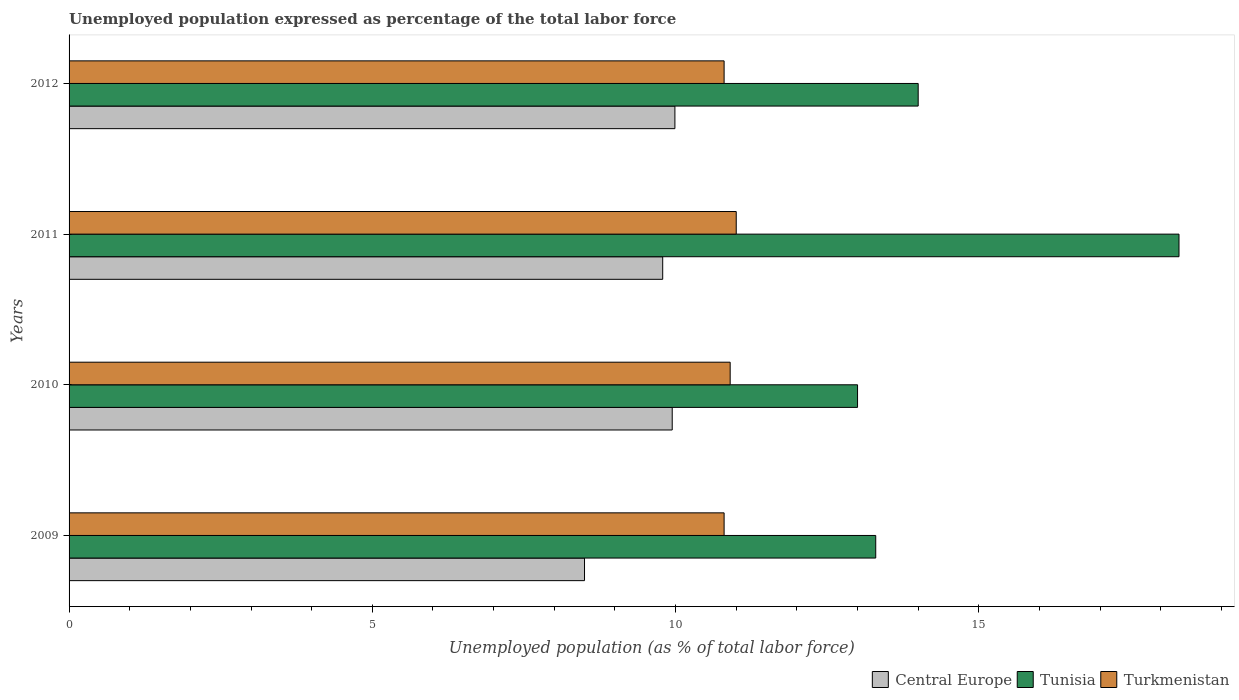Are the number of bars on each tick of the Y-axis equal?
Offer a very short reply. Yes. How many bars are there on the 1st tick from the top?
Provide a succinct answer. 3. How many bars are there on the 2nd tick from the bottom?
Give a very brief answer. 3. What is the unemployment in in Tunisia in 2012?
Provide a short and direct response. 14. Across all years, what is the minimum unemployment in in Central Europe?
Keep it short and to the point. 8.5. What is the total unemployment in in Central Europe in the graph?
Provide a succinct answer. 38.22. What is the difference between the unemployment in in Tunisia in 2010 and that in 2012?
Make the answer very short. -1. What is the difference between the unemployment in in Central Europe in 2010 and the unemployment in in Tunisia in 2011?
Your answer should be compact. -8.36. What is the average unemployment in in Central Europe per year?
Provide a short and direct response. 9.55. In the year 2010, what is the difference between the unemployment in in Central Europe and unemployment in in Tunisia?
Your response must be concise. -3.06. What is the ratio of the unemployment in in Central Europe in 2010 to that in 2011?
Give a very brief answer. 1.02. What is the difference between the highest and the second highest unemployment in in Tunisia?
Provide a succinct answer. 4.3. What is the difference between the highest and the lowest unemployment in in Turkmenistan?
Offer a very short reply. 0.2. In how many years, is the unemployment in in Turkmenistan greater than the average unemployment in in Turkmenistan taken over all years?
Offer a terse response. 2. What does the 1st bar from the top in 2011 represents?
Offer a terse response. Turkmenistan. What does the 3rd bar from the bottom in 2009 represents?
Offer a terse response. Turkmenistan. Is it the case that in every year, the sum of the unemployment in in Tunisia and unemployment in in Central Europe is greater than the unemployment in in Turkmenistan?
Give a very brief answer. Yes. How many bars are there?
Keep it short and to the point. 12. Does the graph contain any zero values?
Provide a short and direct response. No. Where does the legend appear in the graph?
Offer a very short reply. Bottom right. How many legend labels are there?
Give a very brief answer. 3. What is the title of the graph?
Give a very brief answer. Unemployed population expressed as percentage of the total labor force. Does "Brazil" appear as one of the legend labels in the graph?
Your response must be concise. No. What is the label or title of the X-axis?
Offer a very short reply. Unemployed population (as % of total labor force). What is the label or title of the Y-axis?
Give a very brief answer. Years. What is the Unemployed population (as % of total labor force) in Central Europe in 2009?
Give a very brief answer. 8.5. What is the Unemployed population (as % of total labor force) of Tunisia in 2009?
Provide a short and direct response. 13.3. What is the Unemployed population (as % of total labor force) of Turkmenistan in 2009?
Your answer should be very brief. 10.8. What is the Unemployed population (as % of total labor force) of Central Europe in 2010?
Offer a terse response. 9.94. What is the Unemployed population (as % of total labor force) of Turkmenistan in 2010?
Your answer should be compact. 10.9. What is the Unemployed population (as % of total labor force) of Central Europe in 2011?
Provide a succinct answer. 9.79. What is the Unemployed population (as % of total labor force) of Tunisia in 2011?
Your answer should be very brief. 18.3. What is the Unemployed population (as % of total labor force) in Turkmenistan in 2011?
Your answer should be compact. 11. What is the Unemployed population (as % of total labor force) of Central Europe in 2012?
Give a very brief answer. 9.99. What is the Unemployed population (as % of total labor force) in Tunisia in 2012?
Your response must be concise. 14. What is the Unemployed population (as % of total labor force) in Turkmenistan in 2012?
Your answer should be very brief. 10.8. Across all years, what is the maximum Unemployed population (as % of total labor force) in Central Europe?
Ensure brevity in your answer.  9.99. Across all years, what is the maximum Unemployed population (as % of total labor force) of Tunisia?
Your answer should be very brief. 18.3. Across all years, what is the maximum Unemployed population (as % of total labor force) of Turkmenistan?
Provide a succinct answer. 11. Across all years, what is the minimum Unemployed population (as % of total labor force) in Central Europe?
Keep it short and to the point. 8.5. Across all years, what is the minimum Unemployed population (as % of total labor force) of Tunisia?
Provide a short and direct response. 13. Across all years, what is the minimum Unemployed population (as % of total labor force) of Turkmenistan?
Make the answer very short. 10.8. What is the total Unemployed population (as % of total labor force) in Central Europe in the graph?
Your response must be concise. 38.22. What is the total Unemployed population (as % of total labor force) of Tunisia in the graph?
Your answer should be very brief. 58.6. What is the total Unemployed population (as % of total labor force) of Turkmenistan in the graph?
Offer a very short reply. 43.5. What is the difference between the Unemployed population (as % of total labor force) in Central Europe in 2009 and that in 2010?
Your answer should be very brief. -1.45. What is the difference between the Unemployed population (as % of total labor force) in Turkmenistan in 2009 and that in 2010?
Keep it short and to the point. -0.1. What is the difference between the Unemployed population (as % of total labor force) in Central Europe in 2009 and that in 2011?
Offer a terse response. -1.29. What is the difference between the Unemployed population (as % of total labor force) in Tunisia in 2009 and that in 2011?
Your answer should be compact. -5. What is the difference between the Unemployed population (as % of total labor force) of Turkmenistan in 2009 and that in 2011?
Provide a short and direct response. -0.2. What is the difference between the Unemployed population (as % of total labor force) of Central Europe in 2009 and that in 2012?
Give a very brief answer. -1.49. What is the difference between the Unemployed population (as % of total labor force) of Turkmenistan in 2009 and that in 2012?
Give a very brief answer. 0. What is the difference between the Unemployed population (as % of total labor force) of Central Europe in 2010 and that in 2011?
Your response must be concise. 0.16. What is the difference between the Unemployed population (as % of total labor force) in Tunisia in 2010 and that in 2011?
Provide a succinct answer. -5.3. What is the difference between the Unemployed population (as % of total labor force) in Turkmenistan in 2010 and that in 2011?
Give a very brief answer. -0.1. What is the difference between the Unemployed population (as % of total labor force) of Central Europe in 2010 and that in 2012?
Offer a terse response. -0.04. What is the difference between the Unemployed population (as % of total labor force) in Turkmenistan in 2010 and that in 2012?
Keep it short and to the point. 0.1. What is the difference between the Unemployed population (as % of total labor force) in Central Europe in 2011 and that in 2012?
Your answer should be very brief. -0.2. What is the difference between the Unemployed population (as % of total labor force) of Tunisia in 2011 and that in 2012?
Offer a very short reply. 4.3. What is the difference between the Unemployed population (as % of total labor force) in Central Europe in 2009 and the Unemployed population (as % of total labor force) in Tunisia in 2010?
Your answer should be compact. -4.5. What is the difference between the Unemployed population (as % of total labor force) of Central Europe in 2009 and the Unemployed population (as % of total labor force) of Turkmenistan in 2010?
Offer a terse response. -2.4. What is the difference between the Unemployed population (as % of total labor force) in Tunisia in 2009 and the Unemployed population (as % of total labor force) in Turkmenistan in 2010?
Ensure brevity in your answer.  2.4. What is the difference between the Unemployed population (as % of total labor force) in Central Europe in 2009 and the Unemployed population (as % of total labor force) in Tunisia in 2011?
Your answer should be compact. -9.8. What is the difference between the Unemployed population (as % of total labor force) in Central Europe in 2009 and the Unemployed population (as % of total labor force) in Turkmenistan in 2011?
Make the answer very short. -2.5. What is the difference between the Unemployed population (as % of total labor force) of Central Europe in 2009 and the Unemployed population (as % of total labor force) of Tunisia in 2012?
Your answer should be very brief. -5.5. What is the difference between the Unemployed population (as % of total labor force) in Central Europe in 2009 and the Unemployed population (as % of total labor force) in Turkmenistan in 2012?
Make the answer very short. -2.3. What is the difference between the Unemployed population (as % of total labor force) in Tunisia in 2009 and the Unemployed population (as % of total labor force) in Turkmenistan in 2012?
Your answer should be very brief. 2.5. What is the difference between the Unemployed population (as % of total labor force) of Central Europe in 2010 and the Unemployed population (as % of total labor force) of Tunisia in 2011?
Your answer should be compact. -8.36. What is the difference between the Unemployed population (as % of total labor force) in Central Europe in 2010 and the Unemployed population (as % of total labor force) in Turkmenistan in 2011?
Offer a terse response. -1.06. What is the difference between the Unemployed population (as % of total labor force) in Tunisia in 2010 and the Unemployed population (as % of total labor force) in Turkmenistan in 2011?
Ensure brevity in your answer.  2. What is the difference between the Unemployed population (as % of total labor force) in Central Europe in 2010 and the Unemployed population (as % of total labor force) in Tunisia in 2012?
Your answer should be compact. -4.06. What is the difference between the Unemployed population (as % of total labor force) of Central Europe in 2010 and the Unemployed population (as % of total labor force) of Turkmenistan in 2012?
Your answer should be compact. -0.86. What is the difference between the Unemployed population (as % of total labor force) in Central Europe in 2011 and the Unemployed population (as % of total labor force) in Tunisia in 2012?
Provide a short and direct response. -4.21. What is the difference between the Unemployed population (as % of total labor force) of Central Europe in 2011 and the Unemployed population (as % of total labor force) of Turkmenistan in 2012?
Offer a terse response. -1.01. What is the difference between the Unemployed population (as % of total labor force) of Tunisia in 2011 and the Unemployed population (as % of total labor force) of Turkmenistan in 2012?
Offer a very short reply. 7.5. What is the average Unemployed population (as % of total labor force) in Central Europe per year?
Your answer should be compact. 9.55. What is the average Unemployed population (as % of total labor force) in Tunisia per year?
Provide a succinct answer. 14.65. What is the average Unemployed population (as % of total labor force) in Turkmenistan per year?
Give a very brief answer. 10.88. In the year 2009, what is the difference between the Unemployed population (as % of total labor force) in Central Europe and Unemployed population (as % of total labor force) in Tunisia?
Provide a succinct answer. -4.8. In the year 2009, what is the difference between the Unemployed population (as % of total labor force) of Central Europe and Unemployed population (as % of total labor force) of Turkmenistan?
Your answer should be compact. -2.3. In the year 2010, what is the difference between the Unemployed population (as % of total labor force) of Central Europe and Unemployed population (as % of total labor force) of Tunisia?
Your answer should be compact. -3.06. In the year 2010, what is the difference between the Unemployed population (as % of total labor force) in Central Europe and Unemployed population (as % of total labor force) in Turkmenistan?
Give a very brief answer. -0.96. In the year 2010, what is the difference between the Unemployed population (as % of total labor force) in Tunisia and Unemployed population (as % of total labor force) in Turkmenistan?
Offer a terse response. 2.1. In the year 2011, what is the difference between the Unemployed population (as % of total labor force) of Central Europe and Unemployed population (as % of total labor force) of Tunisia?
Make the answer very short. -8.51. In the year 2011, what is the difference between the Unemployed population (as % of total labor force) in Central Europe and Unemployed population (as % of total labor force) in Turkmenistan?
Ensure brevity in your answer.  -1.21. In the year 2012, what is the difference between the Unemployed population (as % of total labor force) of Central Europe and Unemployed population (as % of total labor force) of Tunisia?
Your answer should be very brief. -4.01. In the year 2012, what is the difference between the Unemployed population (as % of total labor force) of Central Europe and Unemployed population (as % of total labor force) of Turkmenistan?
Provide a short and direct response. -0.81. What is the ratio of the Unemployed population (as % of total labor force) in Central Europe in 2009 to that in 2010?
Offer a terse response. 0.85. What is the ratio of the Unemployed population (as % of total labor force) in Tunisia in 2009 to that in 2010?
Give a very brief answer. 1.02. What is the ratio of the Unemployed population (as % of total labor force) in Turkmenistan in 2009 to that in 2010?
Provide a succinct answer. 0.99. What is the ratio of the Unemployed population (as % of total labor force) in Central Europe in 2009 to that in 2011?
Give a very brief answer. 0.87. What is the ratio of the Unemployed population (as % of total labor force) of Tunisia in 2009 to that in 2011?
Your answer should be compact. 0.73. What is the ratio of the Unemployed population (as % of total labor force) in Turkmenistan in 2009 to that in 2011?
Provide a succinct answer. 0.98. What is the ratio of the Unemployed population (as % of total labor force) of Central Europe in 2009 to that in 2012?
Give a very brief answer. 0.85. What is the ratio of the Unemployed population (as % of total labor force) in Tunisia in 2009 to that in 2012?
Make the answer very short. 0.95. What is the ratio of the Unemployed population (as % of total labor force) in Turkmenistan in 2009 to that in 2012?
Your answer should be very brief. 1. What is the ratio of the Unemployed population (as % of total labor force) in Tunisia in 2010 to that in 2011?
Ensure brevity in your answer.  0.71. What is the ratio of the Unemployed population (as % of total labor force) of Turkmenistan in 2010 to that in 2011?
Your answer should be very brief. 0.99. What is the ratio of the Unemployed population (as % of total labor force) of Turkmenistan in 2010 to that in 2012?
Offer a terse response. 1.01. What is the ratio of the Unemployed population (as % of total labor force) of Central Europe in 2011 to that in 2012?
Keep it short and to the point. 0.98. What is the ratio of the Unemployed population (as % of total labor force) in Tunisia in 2011 to that in 2012?
Keep it short and to the point. 1.31. What is the ratio of the Unemployed population (as % of total labor force) of Turkmenistan in 2011 to that in 2012?
Your response must be concise. 1.02. What is the difference between the highest and the second highest Unemployed population (as % of total labor force) in Central Europe?
Offer a very short reply. 0.04. What is the difference between the highest and the second highest Unemployed population (as % of total labor force) in Tunisia?
Keep it short and to the point. 4.3. What is the difference between the highest and the lowest Unemployed population (as % of total labor force) of Central Europe?
Your response must be concise. 1.49. What is the difference between the highest and the lowest Unemployed population (as % of total labor force) in Turkmenistan?
Give a very brief answer. 0.2. 